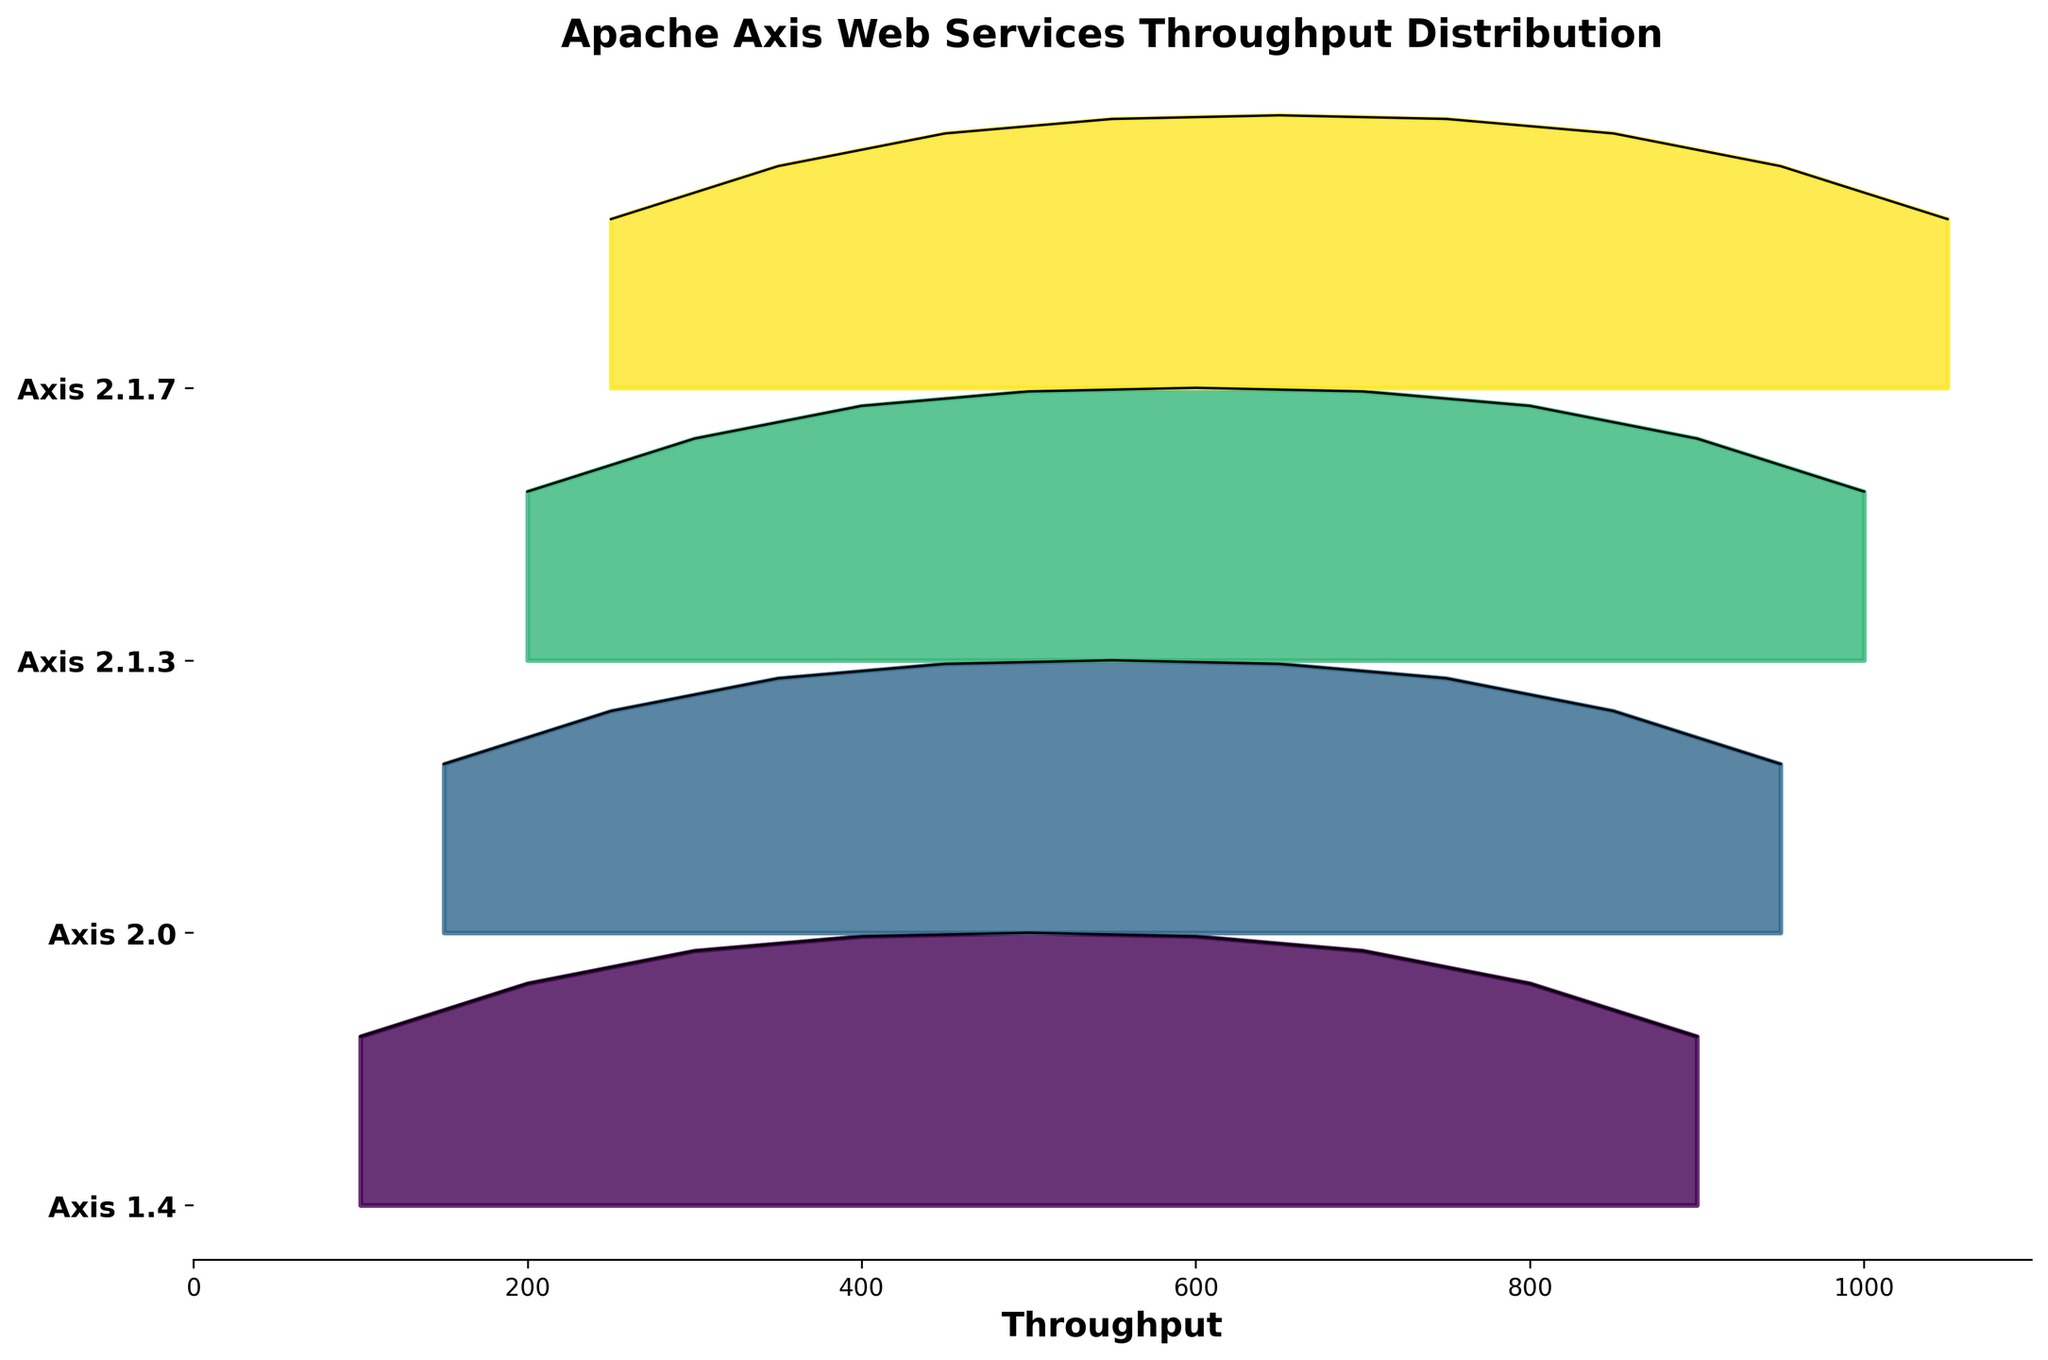What is the title of the plot? The title of the plot is located at the top and is clear and bold. It is "Apache Axis Web Services Throughput Distribution".
Answer: Apache Axis Web Services Throughput Distribution What are the versions of Apache Axis shown in the plot? The versions of Apache Axis are listed on the y-axis, indicated by labels at each horizontal alignment. They are "Axis 1.4", "Axis 2.0", "Axis 2.1.3", and "Axis 2.1.7".
Answer: Axis 1.4, Axis 2.0, Axis 2.1.3, Axis 2.1.7 What is the range of throughputs displayed in the plot? The x-axis, labeled "Throughput", displays values from the leftmost to rightmost extent of the plot. The range is from 0 to 1100.
Answer: 0 to 1100 Which version has the highest peak in throughput density? By examining the heights of the peaks in the filled areas (density) for each version, Axis 2.1.7 has the highest peak.
Answer: Axis 2.1.7 How many distinct versions of Apache Axis are represented in the plot? The number of distinct versions is shown by the unique labels on the y-axis. There are four of them.
Answer: 4 How does the peak throughput density of Axis 1.4 compare to that of Axis 2.0? Compare the heights of the peaks for throughput density between Axis 1.4 and Axis 2.0. Axis 2.0's peak is higher than that of Axis 1.4.
Answer: Axis 2.0's peak is higher What is the approximate maximum throughput value for Axis 2.1.3? By following the x-axis for the range covered by Axis 2.1.3's density, the maximum throughput value appears to be around 1000.
Answer: Around 1000 In which throughput range does Axis 2.0 have its highest density peak? The highest peak for Axis 2.0 can be identified and traced to the corresponding throughput value on the x-axis, which is around 550.
Answer: Around 550 Describe the variation in throughput density for Axis 2.1.7. The throughput density for Axis 2.1.7 increases up to a certain value and then decreases symmetrically. The peak is at throughput around 650, with symmetrical decrease towards 250 and 1050.
Answer: Increases to 650, then decreases symmetrically Which version has a denser throughput distribution closest to 800? By examining the density curves around the throughput value of 800, Axis 2.1.3 and Axis 2.1.7 both have notable densities, but Axis 2.1.3 appears denser at this point.
Answer: Axis 2.1.3 